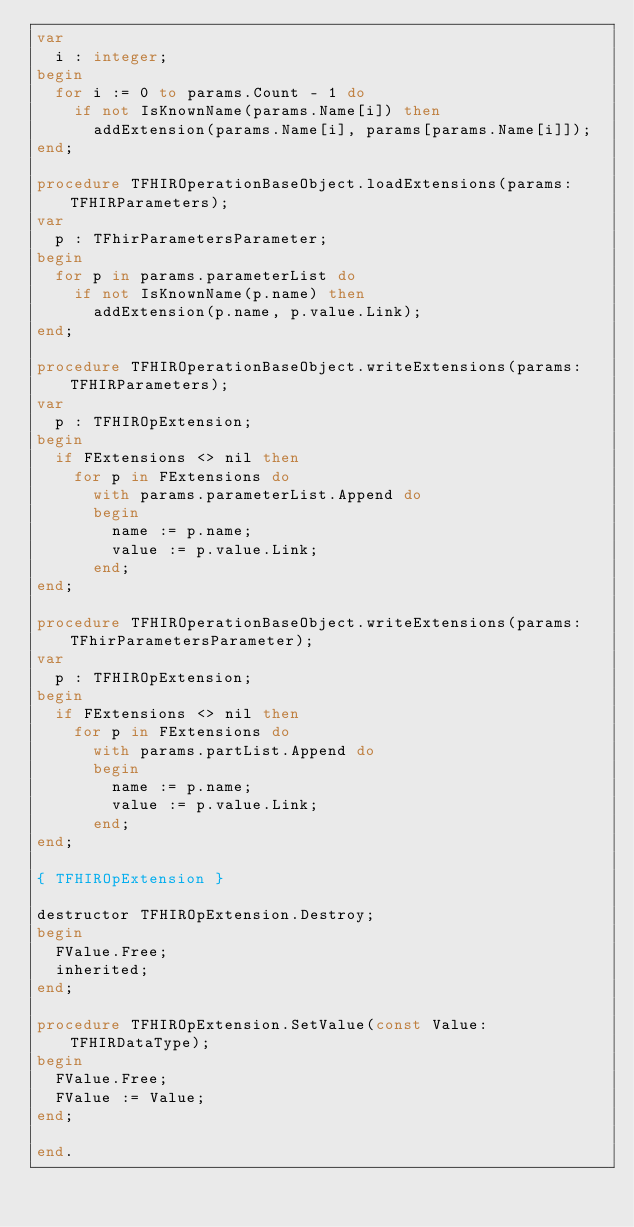<code> <loc_0><loc_0><loc_500><loc_500><_Pascal_>var
  i : integer;
begin
  for i := 0 to params.Count - 1 do
    if not IsKnownName(params.Name[i]) then
      addExtension(params.Name[i], params[params.Name[i]]);
end;

procedure TFHIROperationBaseObject.loadExtensions(params: TFHIRParameters);
var
  p : TFhirParametersParameter;
begin
  for p in params.parameterList do
    if not IsKnownName(p.name) then
      addExtension(p.name, p.value.Link);
end;

procedure TFHIROperationBaseObject.writeExtensions(params: TFHIRParameters);
var
  p : TFHIROpExtension;
begin
  if FExtensions <> nil then
    for p in FExtensions do
      with params.parameterList.Append do
      begin
        name := p.name;
        value := p.value.Link;
      end;
end;

procedure TFHIROperationBaseObject.writeExtensions(params: TFhirParametersParameter);
var
  p : TFHIROpExtension;
begin
  if FExtensions <> nil then
    for p in FExtensions do
      with params.partList.Append do
      begin
        name := p.name;
        value := p.value.Link;
      end;
end;

{ TFHIROpExtension }

destructor TFHIROpExtension.Destroy;
begin
  FValue.Free;
  inherited;
end;

procedure TFHIROpExtension.SetValue(const Value: TFHIRDataType);
begin
  FValue.Free;
  FValue := Value;
end;

end.
</code> 